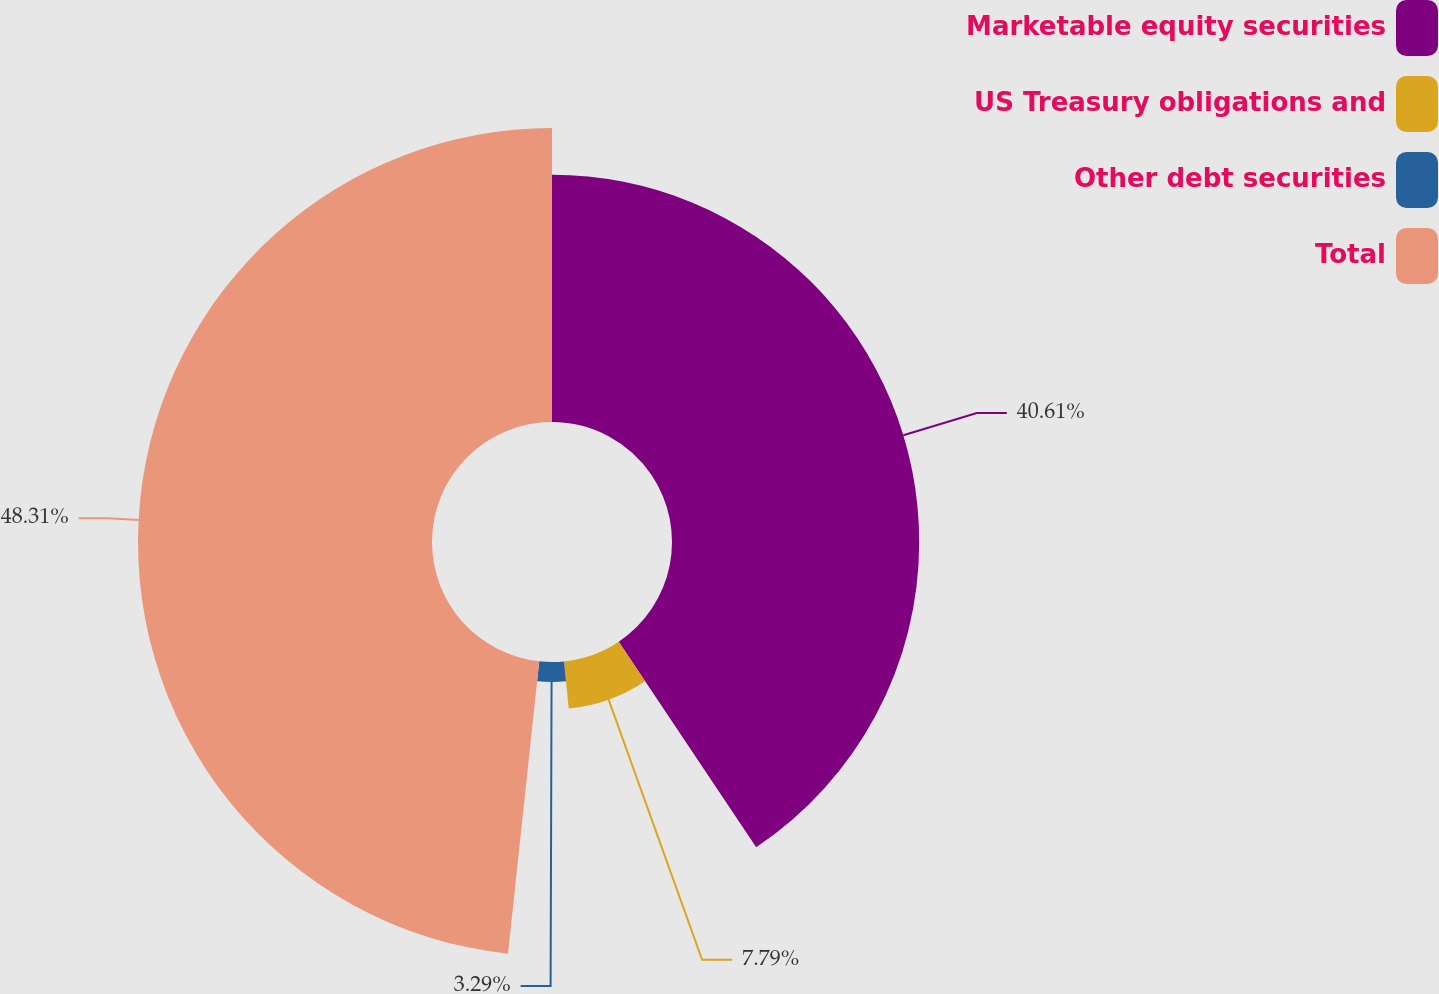Convert chart to OTSL. <chart><loc_0><loc_0><loc_500><loc_500><pie_chart><fcel>Marketable equity securities<fcel>US Treasury obligations and<fcel>Other debt securities<fcel>Total<nl><fcel>40.61%<fcel>7.79%<fcel>3.29%<fcel>48.3%<nl></chart> 